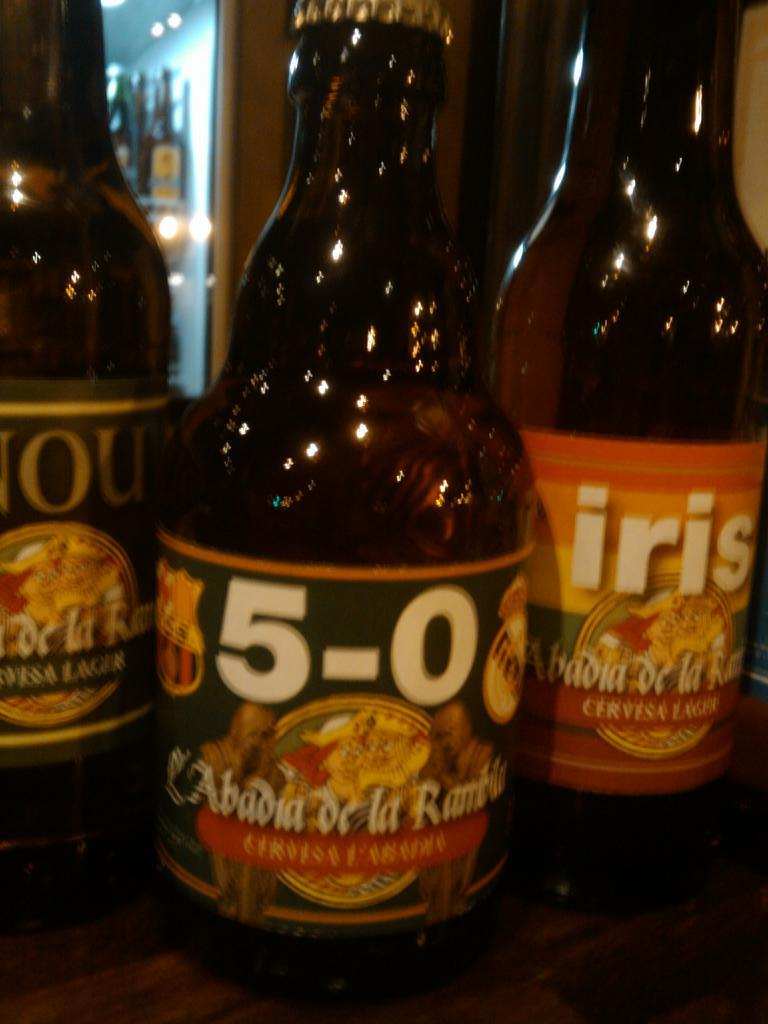<image>
Summarize the visual content of the image. Three bottles and one which reads 5-0 on it 